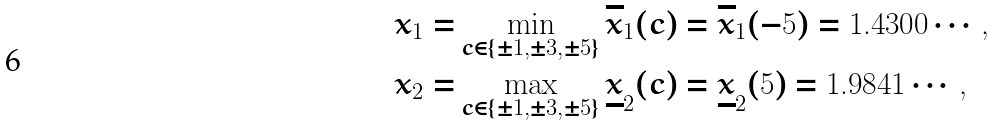<formula> <loc_0><loc_0><loc_500><loc_500>x _ { 1 } = & \min _ { c \in \{ \pm 1 , \pm 3 , \pm 5 \} } \overline { x } _ { 1 } ( c ) = \overline { x } _ { 1 } ( - 5 ) = 1 . 4 3 0 0 \cdots , \\ x _ { 2 } = & \max _ { c \in \{ \pm 1 , \pm 3 , \pm 5 \} } \underline { x } _ { 2 } ( c ) = \underline { x } _ { 2 } ( 5 ) = 1 . 9 8 4 1 \cdots ,</formula> 